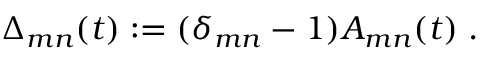Convert formula to latex. <formula><loc_0><loc_0><loc_500><loc_500>\Delta _ { m n } ( t ) \colon = ( \delta _ { m n } - 1 ) A _ { m n } ( t ) \, .</formula> 